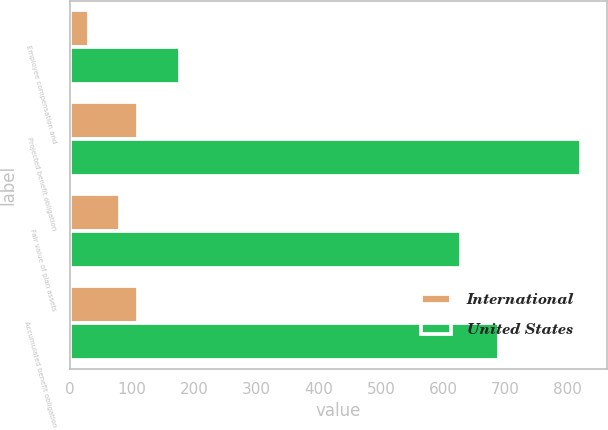Convert chart to OTSL. <chart><loc_0><loc_0><loc_500><loc_500><stacked_bar_chart><ecel><fcel>Employee compensation and<fcel>Projected benefit obligation<fcel>Fair value of plan assets<fcel>Accumulated benefit obligation<nl><fcel>International<fcel>30<fcel>110<fcel>80<fcel>110<nl><fcel>United States<fcel>177<fcel>821<fcel>629<fcel>690<nl></chart> 